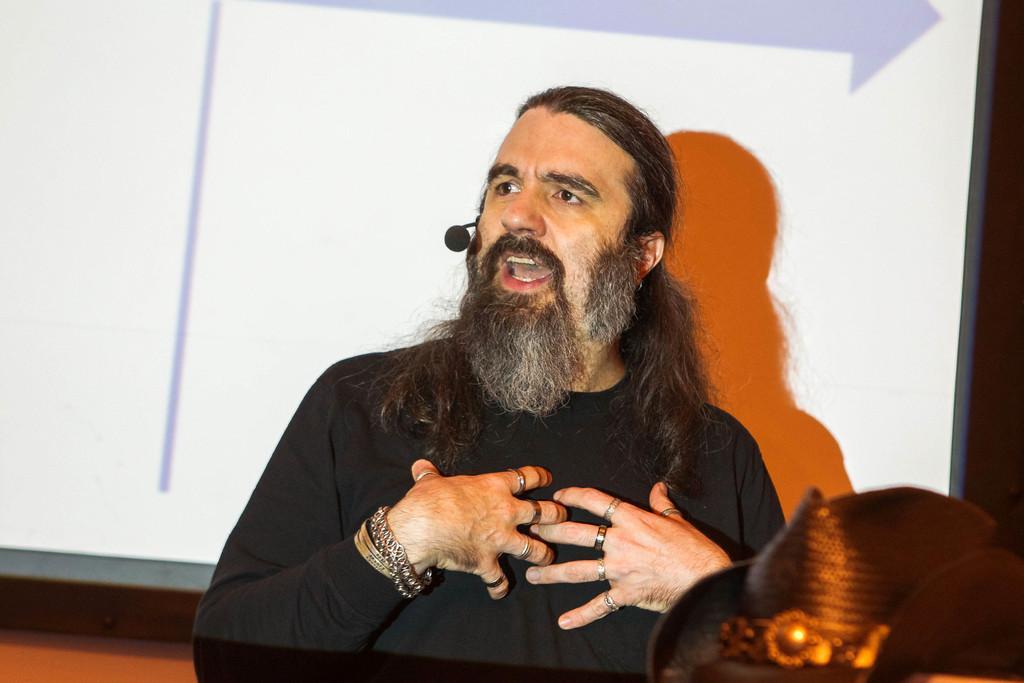In one or two sentences, can you explain what this image depicts? In this picture there is a man talking and wore black t shirt and mic, behind him we can see screen. In the bottom right side of the image we can see hat. 